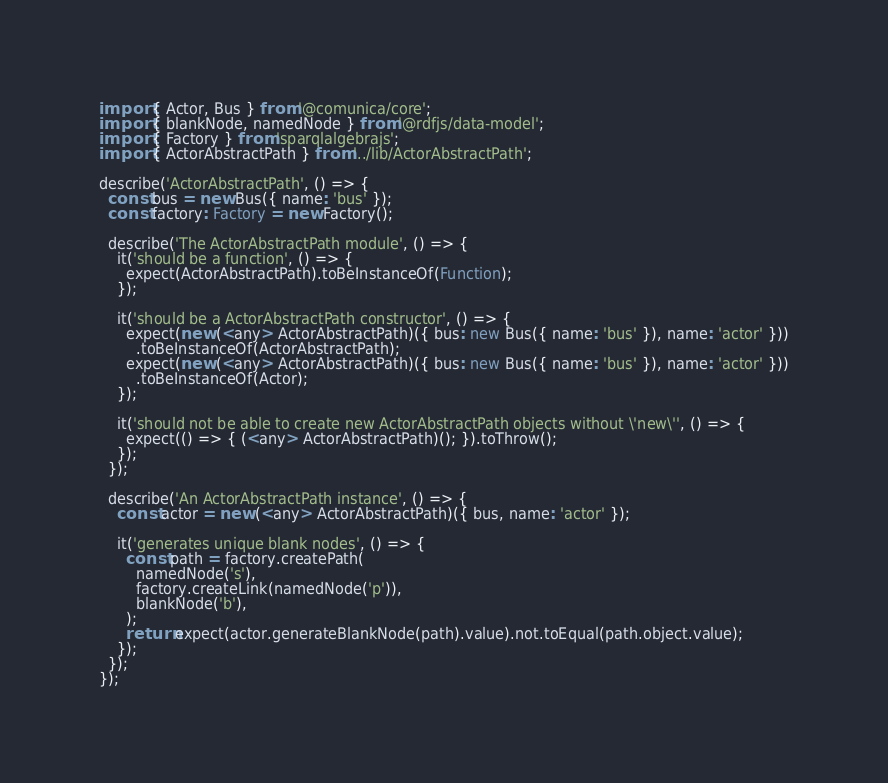Convert code to text. <code><loc_0><loc_0><loc_500><loc_500><_TypeScript_>import { Actor, Bus } from '@comunica/core';
import { blankNode, namedNode } from '@rdfjs/data-model';
import { Factory } from 'sparqlalgebrajs';
import { ActorAbstractPath } from '../lib/ActorAbstractPath';

describe('ActorAbstractPath', () => {
  const bus = new Bus({ name: 'bus' });
  const factory: Factory = new Factory();

  describe('The ActorAbstractPath module', () => {
    it('should be a function', () => {
      expect(ActorAbstractPath).toBeInstanceOf(Function);
    });

    it('should be a ActorAbstractPath constructor', () => {
      expect(new (<any> ActorAbstractPath)({ bus: new Bus({ name: 'bus' }), name: 'actor' }))
        .toBeInstanceOf(ActorAbstractPath);
      expect(new (<any> ActorAbstractPath)({ bus: new Bus({ name: 'bus' }), name: 'actor' }))
        .toBeInstanceOf(Actor);
    });

    it('should not be able to create new ActorAbstractPath objects without \'new\'', () => {
      expect(() => { (<any> ActorAbstractPath)(); }).toThrow();
    });
  });

  describe('An ActorAbstractPath instance', () => {
    const actor = new (<any> ActorAbstractPath)({ bus, name: 'actor' });

    it('generates unique blank nodes', () => {
      const path = factory.createPath(
        namedNode('s'),
        factory.createLink(namedNode('p')),
        blankNode('b'),
      );
      return expect(actor.generateBlankNode(path).value).not.toEqual(path.object.value);
    });
  });
});
</code> 